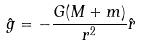<formula> <loc_0><loc_0><loc_500><loc_500>\hat { g } = - \frac { G ( M + m ) } { r ^ { 2 } } \hat { r }</formula> 